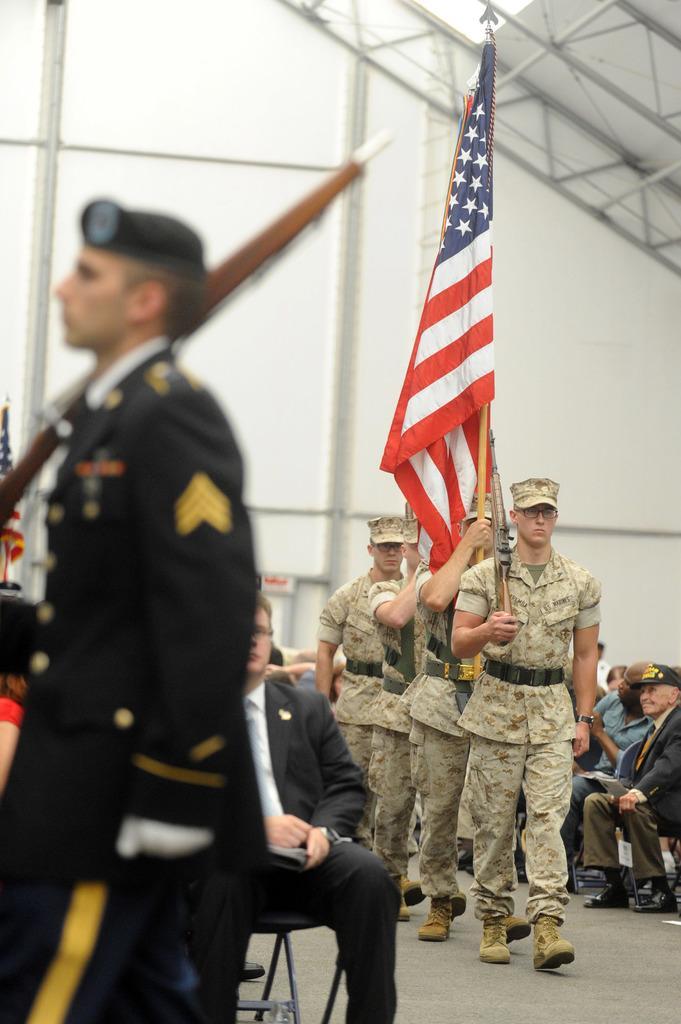Please provide a concise description of this image. In this image, I can see a person standing and few people sitting. This man is holding a gun and walking. I can see another person holding a flag. This is the wall. I think this is an iron pillar. 